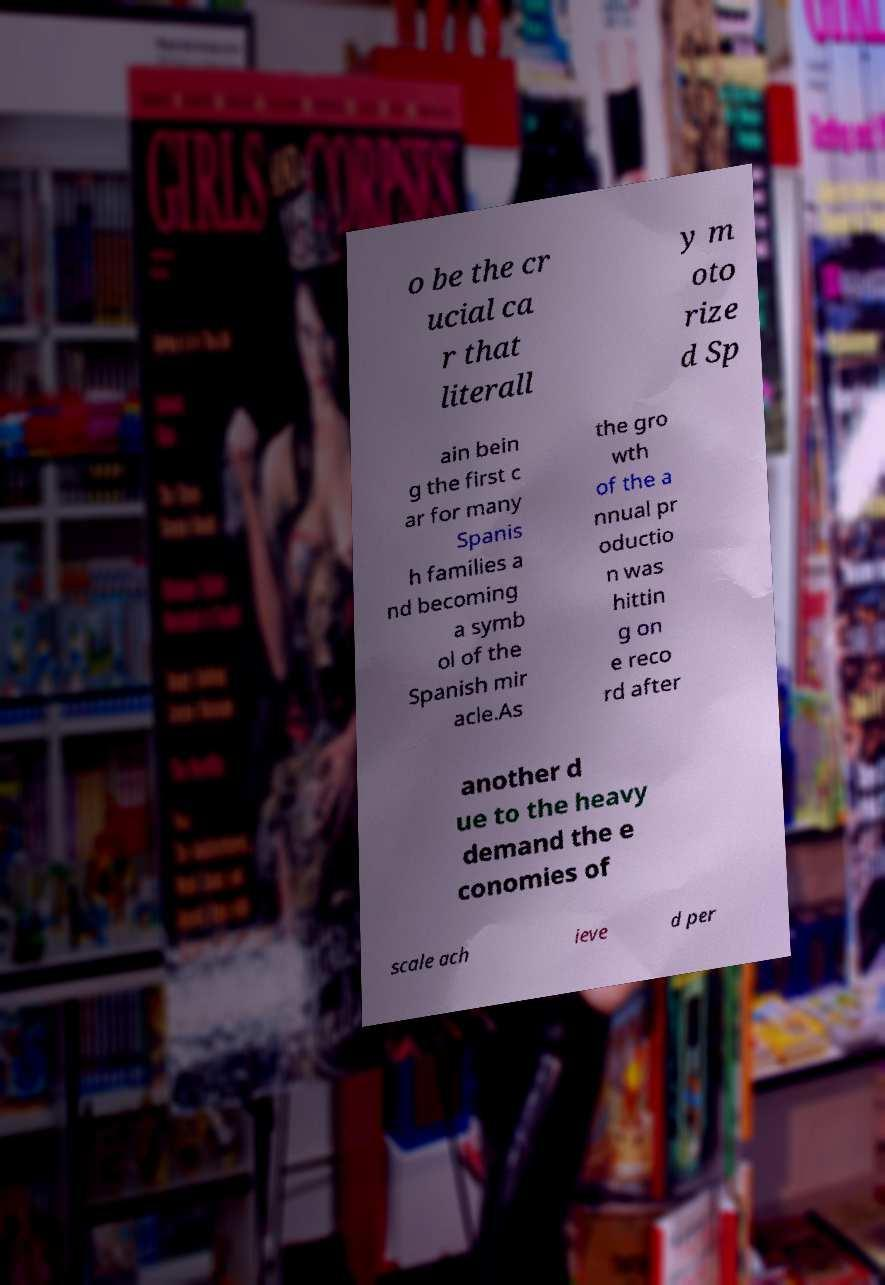There's text embedded in this image that I need extracted. Can you transcribe it verbatim? o be the cr ucial ca r that literall y m oto rize d Sp ain bein g the first c ar for many Spanis h families a nd becoming a symb ol of the Spanish mir acle.As the gro wth of the a nnual pr oductio n was hittin g on e reco rd after another d ue to the heavy demand the e conomies of scale ach ieve d per 